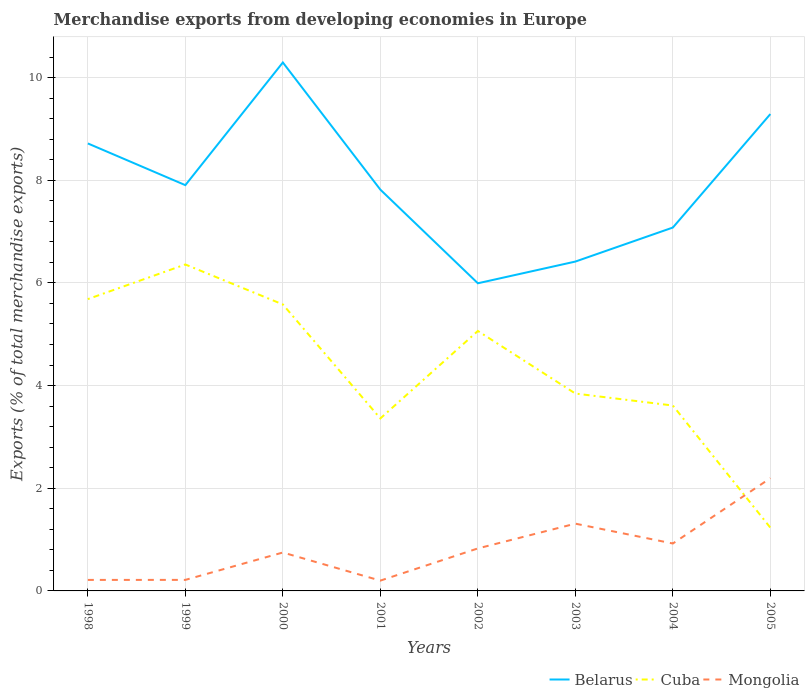Is the number of lines equal to the number of legend labels?
Provide a short and direct response. Yes. Across all years, what is the maximum percentage of total merchandise exports in Belarus?
Make the answer very short. 5.99. In which year was the percentage of total merchandise exports in Mongolia maximum?
Ensure brevity in your answer.  2001. What is the total percentage of total merchandise exports in Cuba in the graph?
Offer a terse response. 2.32. What is the difference between the highest and the second highest percentage of total merchandise exports in Belarus?
Provide a succinct answer. 4.3. What is the difference between the highest and the lowest percentage of total merchandise exports in Cuba?
Make the answer very short. 4. Is the percentage of total merchandise exports in Belarus strictly greater than the percentage of total merchandise exports in Mongolia over the years?
Provide a short and direct response. No. How many lines are there?
Keep it short and to the point. 3. What is the difference between two consecutive major ticks on the Y-axis?
Make the answer very short. 2. Are the values on the major ticks of Y-axis written in scientific E-notation?
Keep it short and to the point. No. Does the graph contain grids?
Offer a terse response. Yes. Where does the legend appear in the graph?
Provide a short and direct response. Bottom right. How many legend labels are there?
Provide a succinct answer. 3. How are the legend labels stacked?
Offer a very short reply. Horizontal. What is the title of the graph?
Ensure brevity in your answer.  Merchandise exports from developing economies in Europe. What is the label or title of the Y-axis?
Keep it short and to the point. Exports (% of total merchandise exports). What is the Exports (% of total merchandise exports) of Belarus in 1998?
Give a very brief answer. 8.72. What is the Exports (% of total merchandise exports) of Cuba in 1998?
Offer a terse response. 5.68. What is the Exports (% of total merchandise exports) in Mongolia in 1998?
Ensure brevity in your answer.  0.21. What is the Exports (% of total merchandise exports) in Belarus in 1999?
Ensure brevity in your answer.  7.9. What is the Exports (% of total merchandise exports) of Cuba in 1999?
Offer a very short reply. 6.36. What is the Exports (% of total merchandise exports) in Mongolia in 1999?
Give a very brief answer. 0.21. What is the Exports (% of total merchandise exports) in Belarus in 2000?
Provide a short and direct response. 10.29. What is the Exports (% of total merchandise exports) in Cuba in 2000?
Give a very brief answer. 5.58. What is the Exports (% of total merchandise exports) of Mongolia in 2000?
Your answer should be very brief. 0.75. What is the Exports (% of total merchandise exports) in Belarus in 2001?
Your response must be concise. 7.82. What is the Exports (% of total merchandise exports) in Cuba in 2001?
Give a very brief answer. 3.36. What is the Exports (% of total merchandise exports) of Mongolia in 2001?
Provide a succinct answer. 0.2. What is the Exports (% of total merchandise exports) in Belarus in 2002?
Make the answer very short. 5.99. What is the Exports (% of total merchandise exports) in Cuba in 2002?
Ensure brevity in your answer.  5.06. What is the Exports (% of total merchandise exports) in Mongolia in 2002?
Offer a very short reply. 0.83. What is the Exports (% of total merchandise exports) of Belarus in 2003?
Make the answer very short. 6.42. What is the Exports (% of total merchandise exports) of Cuba in 2003?
Your answer should be very brief. 3.85. What is the Exports (% of total merchandise exports) of Mongolia in 2003?
Give a very brief answer. 1.31. What is the Exports (% of total merchandise exports) in Belarus in 2004?
Offer a terse response. 7.08. What is the Exports (% of total merchandise exports) of Cuba in 2004?
Provide a succinct answer. 3.61. What is the Exports (% of total merchandise exports) of Mongolia in 2004?
Provide a short and direct response. 0.92. What is the Exports (% of total merchandise exports) of Belarus in 2005?
Offer a very short reply. 9.29. What is the Exports (% of total merchandise exports) in Cuba in 2005?
Ensure brevity in your answer.  1.23. What is the Exports (% of total merchandise exports) in Mongolia in 2005?
Your answer should be very brief. 2.2. Across all years, what is the maximum Exports (% of total merchandise exports) in Belarus?
Make the answer very short. 10.29. Across all years, what is the maximum Exports (% of total merchandise exports) in Cuba?
Give a very brief answer. 6.36. Across all years, what is the maximum Exports (% of total merchandise exports) in Mongolia?
Provide a short and direct response. 2.2. Across all years, what is the minimum Exports (% of total merchandise exports) of Belarus?
Provide a short and direct response. 5.99. Across all years, what is the minimum Exports (% of total merchandise exports) in Cuba?
Give a very brief answer. 1.23. Across all years, what is the minimum Exports (% of total merchandise exports) of Mongolia?
Your answer should be very brief. 0.2. What is the total Exports (% of total merchandise exports) of Belarus in the graph?
Your response must be concise. 63.51. What is the total Exports (% of total merchandise exports) of Cuba in the graph?
Make the answer very short. 34.74. What is the total Exports (% of total merchandise exports) in Mongolia in the graph?
Give a very brief answer. 6.64. What is the difference between the Exports (% of total merchandise exports) of Belarus in 1998 and that in 1999?
Give a very brief answer. 0.81. What is the difference between the Exports (% of total merchandise exports) of Cuba in 1998 and that in 1999?
Ensure brevity in your answer.  -0.67. What is the difference between the Exports (% of total merchandise exports) of Mongolia in 1998 and that in 1999?
Give a very brief answer. -0. What is the difference between the Exports (% of total merchandise exports) in Belarus in 1998 and that in 2000?
Provide a short and direct response. -1.58. What is the difference between the Exports (% of total merchandise exports) in Cuba in 1998 and that in 2000?
Your answer should be very brief. 0.1. What is the difference between the Exports (% of total merchandise exports) in Mongolia in 1998 and that in 2000?
Provide a succinct answer. -0.53. What is the difference between the Exports (% of total merchandise exports) in Belarus in 1998 and that in 2001?
Ensure brevity in your answer.  0.9. What is the difference between the Exports (% of total merchandise exports) of Cuba in 1998 and that in 2001?
Keep it short and to the point. 2.32. What is the difference between the Exports (% of total merchandise exports) of Mongolia in 1998 and that in 2001?
Make the answer very short. 0.01. What is the difference between the Exports (% of total merchandise exports) in Belarus in 1998 and that in 2002?
Provide a succinct answer. 2.72. What is the difference between the Exports (% of total merchandise exports) in Cuba in 1998 and that in 2002?
Give a very brief answer. 0.62. What is the difference between the Exports (% of total merchandise exports) in Mongolia in 1998 and that in 2002?
Give a very brief answer. -0.61. What is the difference between the Exports (% of total merchandise exports) of Belarus in 1998 and that in 2003?
Keep it short and to the point. 2.3. What is the difference between the Exports (% of total merchandise exports) in Cuba in 1998 and that in 2003?
Your response must be concise. 1.84. What is the difference between the Exports (% of total merchandise exports) in Mongolia in 1998 and that in 2003?
Keep it short and to the point. -1.1. What is the difference between the Exports (% of total merchandise exports) in Belarus in 1998 and that in 2004?
Your answer should be very brief. 1.64. What is the difference between the Exports (% of total merchandise exports) in Cuba in 1998 and that in 2004?
Offer a terse response. 2.07. What is the difference between the Exports (% of total merchandise exports) in Mongolia in 1998 and that in 2004?
Keep it short and to the point. -0.71. What is the difference between the Exports (% of total merchandise exports) in Belarus in 1998 and that in 2005?
Keep it short and to the point. -0.57. What is the difference between the Exports (% of total merchandise exports) in Cuba in 1998 and that in 2005?
Provide a succinct answer. 4.45. What is the difference between the Exports (% of total merchandise exports) of Mongolia in 1998 and that in 2005?
Make the answer very short. -1.98. What is the difference between the Exports (% of total merchandise exports) in Belarus in 1999 and that in 2000?
Offer a terse response. -2.39. What is the difference between the Exports (% of total merchandise exports) of Cuba in 1999 and that in 2000?
Provide a short and direct response. 0.78. What is the difference between the Exports (% of total merchandise exports) in Mongolia in 1999 and that in 2000?
Make the answer very short. -0.53. What is the difference between the Exports (% of total merchandise exports) in Belarus in 1999 and that in 2001?
Provide a short and direct response. 0.09. What is the difference between the Exports (% of total merchandise exports) of Cuba in 1999 and that in 2001?
Your answer should be compact. 3. What is the difference between the Exports (% of total merchandise exports) of Mongolia in 1999 and that in 2001?
Offer a terse response. 0.01. What is the difference between the Exports (% of total merchandise exports) in Belarus in 1999 and that in 2002?
Your answer should be compact. 1.91. What is the difference between the Exports (% of total merchandise exports) of Cuba in 1999 and that in 2002?
Ensure brevity in your answer.  1.3. What is the difference between the Exports (% of total merchandise exports) in Mongolia in 1999 and that in 2002?
Ensure brevity in your answer.  -0.61. What is the difference between the Exports (% of total merchandise exports) in Belarus in 1999 and that in 2003?
Provide a succinct answer. 1.49. What is the difference between the Exports (% of total merchandise exports) in Cuba in 1999 and that in 2003?
Offer a very short reply. 2.51. What is the difference between the Exports (% of total merchandise exports) in Mongolia in 1999 and that in 2003?
Keep it short and to the point. -1.1. What is the difference between the Exports (% of total merchandise exports) in Belarus in 1999 and that in 2004?
Offer a terse response. 0.83. What is the difference between the Exports (% of total merchandise exports) in Cuba in 1999 and that in 2004?
Provide a short and direct response. 2.75. What is the difference between the Exports (% of total merchandise exports) in Mongolia in 1999 and that in 2004?
Give a very brief answer. -0.71. What is the difference between the Exports (% of total merchandise exports) in Belarus in 1999 and that in 2005?
Offer a very short reply. -1.39. What is the difference between the Exports (% of total merchandise exports) in Cuba in 1999 and that in 2005?
Provide a short and direct response. 5.13. What is the difference between the Exports (% of total merchandise exports) in Mongolia in 1999 and that in 2005?
Give a very brief answer. -1.98. What is the difference between the Exports (% of total merchandise exports) of Belarus in 2000 and that in 2001?
Your response must be concise. 2.48. What is the difference between the Exports (% of total merchandise exports) of Cuba in 2000 and that in 2001?
Keep it short and to the point. 2.22. What is the difference between the Exports (% of total merchandise exports) in Mongolia in 2000 and that in 2001?
Ensure brevity in your answer.  0.55. What is the difference between the Exports (% of total merchandise exports) in Belarus in 2000 and that in 2002?
Your answer should be compact. 4.3. What is the difference between the Exports (% of total merchandise exports) of Cuba in 2000 and that in 2002?
Provide a short and direct response. 0.52. What is the difference between the Exports (% of total merchandise exports) of Mongolia in 2000 and that in 2002?
Ensure brevity in your answer.  -0.08. What is the difference between the Exports (% of total merchandise exports) of Belarus in 2000 and that in 2003?
Offer a terse response. 3.88. What is the difference between the Exports (% of total merchandise exports) in Cuba in 2000 and that in 2003?
Make the answer very short. 1.74. What is the difference between the Exports (% of total merchandise exports) of Mongolia in 2000 and that in 2003?
Ensure brevity in your answer.  -0.56. What is the difference between the Exports (% of total merchandise exports) of Belarus in 2000 and that in 2004?
Ensure brevity in your answer.  3.22. What is the difference between the Exports (% of total merchandise exports) in Cuba in 2000 and that in 2004?
Make the answer very short. 1.97. What is the difference between the Exports (% of total merchandise exports) of Mongolia in 2000 and that in 2004?
Make the answer very short. -0.18. What is the difference between the Exports (% of total merchandise exports) of Belarus in 2000 and that in 2005?
Your answer should be compact. 1. What is the difference between the Exports (% of total merchandise exports) of Cuba in 2000 and that in 2005?
Keep it short and to the point. 4.35. What is the difference between the Exports (% of total merchandise exports) in Mongolia in 2000 and that in 2005?
Ensure brevity in your answer.  -1.45. What is the difference between the Exports (% of total merchandise exports) of Belarus in 2001 and that in 2002?
Your answer should be very brief. 1.82. What is the difference between the Exports (% of total merchandise exports) of Cuba in 2001 and that in 2002?
Keep it short and to the point. -1.7. What is the difference between the Exports (% of total merchandise exports) in Mongolia in 2001 and that in 2002?
Your response must be concise. -0.63. What is the difference between the Exports (% of total merchandise exports) of Belarus in 2001 and that in 2003?
Keep it short and to the point. 1.4. What is the difference between the Exports (% of total merchandise exports) of Cuba in 2001 and that in 2003?
Keep it short and to the point. -0.48. What is the difference between the Exports (% of total merchandise exports) of Mongolia in 2001 and that in 2003?
Provide a succinct answer. -1.11. What is the difference between the Exports (% of total merchandise exports) of Belarus in 2001 and that in 2004?
Your answer should be compact. 0.74. What is the difference between the Exports (% of total merchandise exports) in Cuba in 2001 and that in 2004?
Offer a very short reply. -0.25. What is the difference between the Exports (% of total merchandise exports) of Mongolia in 2001 and that in 2004?
Ensure brevity in your answer.  -0.72. What is the difference between the Exports (% of total merchandise exports) of Belarus in 2001 and that in 2005?
Offer a terse response. -1.47. What is the difference between the Exports (% of total merchandise exports) in Cuba in 2001 and that in 2005?
Provide a short and direct response. 2.13. What is the difference between the Exports (% of total merchandise exports) of Mongolia in 2001 and that in 2005?
Provide a succinct answer. -2. What is the difference between the Exports (% of total merchandise exports) of Belarus in 2002 and that in 2003?
Give a very brief answer. -0.42. What is the difference between the Exports (% of total merchandise exports) of Cuba in 2002 and that in 2003?
Keep it short and to the point. 1.22. What is the difference between the Exports (% of total merchandise exports) in Mongolia in 2002 and that in 2003?
Give a very brief answer. -0.48. What is the difference between the Exports (% of total merchandise exports) in Belarus in 2002 and that in 2004?
Provide a succinct answer. -1.09. What is the difference between the Exports (% of total merchandise exports) of Cuba in 2002 and that in 2004?
Provide a short and direct response. 1.45. What is the difference between the Exports (% of total merchandise exports) in Mongolia in 2002 and that in 2004?
Provide a short and direct response. -0.1. What is the difference between the Exports (% of total merchandise exports) of Belarus in 2002 and that in 2005?
Provide a succinct answer. -3.3. What is the difference between the Exports (% of total merchandise exports) of Cuba in 2002 and that in 2005?
Your answer should be very brief. 3.83. What is the difference between the Exports (% of total merchandise exports) in Mongolia in 2002 and that in 2005?
Keep it short and to the point. -1.37. What is the difference between the Exports (% of total merchandise exports) of Belarus in 2003 and that in 2004?
Your answer should be compact. -0.66. What is the difference between the Exports (% of total merchandise exports) of Cuba in 2003 and that in 2004?
Keep it short and to the point. 0.23. What is the difference between the Exports (% of total merchandise exports) of Mongolia in 2003 and that in 2004?
Offer a very short reply. 0.39. What is the difference between the Exports (% of total merchandise exports) of Belarus in 2003 and that in 2005?
Provide a succinct answer. -2.87. What is the difference between the Exports (% of total merchandise exports) in Cuba in 2003 and that in 2005?
Offer a terse response. 2.61. What is the difference between the Exports (% of total merchandise exports) of Mongolia in 2003 and that in 2005?
Give a very brief answer. -0.89. What is the difference between the Exports (% of total merchandise exports) of Belarus in 2004 and that in 2005?
Give a very brief answer. -2.21. What is the difference between the Exports (% of total merchandise exports) in Cuba in 2004 and that in 2005?
Your answer should be compact. 2.38. What is the difference between the Exports (% of total merchandise exports) in Mongolia in 2004 and that in 2005?
Provide a short and direct response. -1.27. What is the difference between the Exports (% of total merchandise exports) of Belarus in 1998 and the Exports (% of total merchandise exports) of Cuba in 1999?
Offer a very short reply. 2.36. What is the difference between the Exports (% of total merchandise exports) in Belarus in 1998 and the Exports (% of total merchandise exports) in Mongolia in 1999?
Give a very brief answer. 8.5. What is the difference between the Exports (% of total merchandise exports) in Cuba in 1998 and the Exports (% of total merchandise exports) in Mongolia in 1999?
Make the answer very short. 5.47. What is the difference between the Exports (% of total merchandise exports) in Belarus in 1998 and the Exports (% of total merchandise exports) in Cuba in 2000?
Your response must be concise. 3.14. What is the difference between the Exports (% of total merchandise exports) in Belarus in 1998 and the Exports (% of total merchandise exports) in Mongolia in 2000?
Keep it short and to the point. 7.97. What is the difference between the Exports (% of total merchandise exports) of Cuba in 1998 and the Exports (% of total merchandise exports) of Mongolia in 2000?
Make the answer very short. 4.94. What is the difference between the Exports (% of total merchandise exports) in Belarus in 1998 and the Exports (% of total merchandise exports) in Cuba in 2001?
Give a very brief answer. 5.36. What is the difference between the Exports (% of total merchandise exports) in Belarus in 1998 and the Exports (% of total merchandise exports) in Mongolia in 2001?
Make the answer very short. 8.52. What is the difference between the Exports (% of total merchandise exports) of Cuba in 1998 and the Exports (% of total merchandise exports) of Mongolia in 2001?
Offer a terse response. 5.48. What is the difference between the Exports (% of total merchandise exports) in Belarus in 1998 and the Exports (% of total merchandise exports) in Cuba in 2002?
Your answer should be very brief. 3.65. What is the difference between the Exports (% of total merchandise exports) of Belarus in 1998 and the Exports (% of total merchandise exports) of Mongolia in 2002?
Your answer should be very brief. 7.89. What is the difference between the Exports (% of total merchandise exports) in Cuba in 1998 and the Exports (% of total merchandise exports) in Mongolia in 2002?
Offer a terse response. 4.86. What is the difference between the Exports (% of total merchandise exports) of Belarus in 1998 and the Exports (% of total merchandise exports) of Cuba in 2003?
Give a very brief answer. 4.87. What is the difference between the Exports (% of total merchandise exports) of Belarus in 1998 and the Exports (% of total merchandise exports) of Mongolia in 2003?
Provide a short and direct response. 7.41. What is the difference between the Exports (% of total merchandise exports) of Cuba in 1998 and the Exports (% of total merchandise exports) of Mongolia in 2003?
Your answer should be compact. 4.37. What is the difference between the Exports (% of total merchandise exports) in Belarus in 1998 and the Exports (% of total merchandise exports) in Cuba in 2004?
Make the answer very short. 5.11. What is the difference between the Exports (% of total merchandise exports) in Belarus in 1998 and the Exports (% of total merchandise exports) in Mongolia in 2004?
Offer a terse response. 7.79. What is the difference between the Exports (% of total merchandise exports) in Cuba in 1998 and the Exports (% of total merchandise exports) in Mongolia in 2004?
Provide a short and direct response. 4.76. What is the difference between the Exports (% of total merchandise exports) of Belarus in 1998 and the Exports (% of total merchandise exports) of Cuba in 2005?
Your answer should be compact. 7.49. What is the difference between the Exports (% of total merchandise exports) in Belarus in 1998 and the Exports (% of total merchandise exports) in Mongolia in 2005?
Provide a succinct answer. 6.52. What is the difference between the Exports (% of total merchandise exports) of Cuba in 1998 and the Exports (% of total merchandise exports) of Mongolia in 2005?
Your answer should be very brief. 3.49. What is the difference between the Exports (% of total merchandise exports) of Belarus in 1999 and the Exports (% of total merchandise exports) of Cuba in 2000?
Offer a very short reply. 2.32. What is the difference between the Exports (% of total merchandise exports) of Belarus in 1999 and the Exports (% of total merchandise exports) of Mongolia in 2000?
Your answer should be compact. 7.16. What is the difference between the Exports (% of total merchandise exports) of Cuba in 1999 and the Exports (% of total merchandise exports) of Mongolia in 2000?
Make the answer very short. 5.61. What is the difference between the Exports (% of total merchandise exports) of Belarus in 1999 and the Exports (% of total merchandise exports) of Cuba in 2001?
Offer a terse response. 4.54. What is the difference between the Exports (% of total merchandise exports) of Belarus in 1999 and the Exports (% of total merchandise exports) of Mongolia in 2001?
Ensure brevity in your answer.  7.7. What is the difference between the Exports (% of total merchandise exports) in Cuba in 1999 and the Exports (% of total merchandise exports) in Mongolia in 2001?
Make the answer very short. 6.16. What is the difference between the Exports (% of total merchandise exports) in Belarus in 1999 and the Exports (% of total merchandise exports) in Cuba in 2002?
Your answer should be compact. 2.84. What is the difference between the Exports (% of total merchandise exports) in Belarus in 1999 and the Exports (% of total merchandise exports) in Mongolia in 2002?
Give a very brief answer. 7.08. What is the difference between the Exports (% of total merchandise exports) of Cuba in 1999 and the Exports (% of total merchandise exports) of Mongolia in 2002?
Your answer should be compact. 5.53. What is the difference between the Exports (% of total merchandise exports) in Belarus in 1999 and the Exports (% of total merchandise exports) in Cuba in 2003?
Ensure brevity in your answer.  4.06. What is the difference between the Exports (% of total merchandise exports) in Belarus in 1999 and the Exports (% of total merchandise exports) in Mongolia in 2003?
Offer a terse response. 6.59. What is the difference between the Exports (% of total merchandise exports) of Cuba in 1999 and the Exports (% of total merchandise exports) of Mongolia in 2003?
Your answer should be very brief. 5.05. What is the difference between the Exports (% of total merchandise exports) in Belarus in 1999 and the Exports (% of total merchandise exports) in Cuba in 2004?
Your response must be concise. 4.29. What is the difference between the Exports (% of total merchandise exports) in Belarus in 1999 and the Exports (% of total merchandise exports) in Mongolia in 2004?
Give a very brief answer. 6.98. What is the difference between the Exports (% of total merchandise exports) of Cuba in 1999 and the Exports (% of total merchandise exports) of Mongolia in 2004?
Provide a succinct answer. 5.44. What is the difference between the Exports (% of total merchandise exports) of Belarus in 1999 and the Exports (% of total merchandise exports) of Cuba in 2005?
Provide a succinct answer. 6.67. What is the difference between the Exports (% of total merchandise exports) of Belarus in 1999 and the Exports (% of total merchandise exports) of Mongolia in 2005?
Offer a very short reply. 5.71. What is the difference between the Exports (% of total merchandise exports) in Cuba in 1999 and the Exports (% of total merchandise exports) in Mongolia in 2005?
Provide a succinct answer. 4.16. What is the difference between the Exports (% of total merchandise exports) of Belarus in 2000 and the Exports (% of total merchandise exports) of Cuba in 2001?
Provide a succinct answer. 6.93. What is the difference between the Exports (% of total merchandise exports) in Belarus in 2000 and the Exports (% of total merchandise exports) in Mongolia in 2001?
Your response must be concise. 10.09. What is the difference between the Exports (% of total merchandise exports) in Cuba in 2000 and the Exports (% of total merchandise exports) in Mongolia in 2001?
Provide a short and direct response. 5.38. What is the difference between the Exports (% of total merchandise exports) of Belarus in 2000 and the Exports (% of total merchandise exports) of Cuba in 2002?
Provide a short and direct response. 5.23. What is the difference between the Exports (% of total merchandise exports) in Belarus in 2000 and the Exports (% of total merchandise exports) in Mongolia in 2002?
Your answer should be very brief. 9.47. What is the difference between the Exports (% of total merchandise exports) of Cuba in 2000 and the Exports (% of total merchandise exports) of Mongolia in 2002?
Provide a succinct answer. 4.75. What is the difference between the Exports (% of total merchandise exports) in Belarus in 2000 and the Exports (% of total merchandise exports) in Cuba in 2003?
Keep it short and to the point. 6.45. What is the difference between the Exports (% of total merchandise exports) in Belarus in 2000 and the Exports (% of total merchandise exports) in Mongolia in 2003?
Ensure brevity in your answer.  8.98. What is the difference between the Exports (% of total merchandise exports) in Cuba in 2000 and the Exports (% of total merchandise exports) in Mongolia in 2003?
Give a very brief answer. 4.27. What is the difference between the Exports (% of total merchandise exports) in Belarus in 2000 and the Exports (% of total merchandise exports) in Cuba in 2004?
Your answer should be compact. 6.68. What is the difference between the Exports (% of total merchandise exports) of Belarus in 2000 and the Exports (% of total merchandise exports) of Mongolia in 2004?
Provide a short and direct response. 9.37. What is the difference between the Exports (% of total merchandise exports) in Cuba in 2000 and the Exports (% of total merchandise exports) in Mongolia in 2004?
Provide a succinct answer. 4.66. What is the difference between the Exports (% of total merchandise exports) of Belarus in 2000 and the Exports (% of total merchandise exports) of Cuba in 2005?
Keep it short and to the point. 9.06. What is the difference between the Exports (% of total merchandise exports) of Belarus in 2000 and the Exports (% of total merchandise exports) of Mongolia in 2005?
Your response must be concise. 8.1. What is the difference between the Exports (% of total merchandise exports) of Cuba in 2000 and the Exports (% of total merchandise exports) of Mongolia in 2005?
Your answer should be compact. 3.38. What is the difference between the Exports (% of total merchandise exports) in Belarus in 2001 and the Exports (% of total merchandise exports) in Cuba in 2002?
Keep it short and to the point. 2.75. What is the difference between the Exports (% of total merchandise exports) in Belarus in 2001 and the Exports (% of total merchandise exports) in Mongolia in 2002?
Give a very brief answer. 6.99. What is the difference between the Exports (% of total merchandise exports) in Cuba in 2001 and the Exports (% of total merchandise exports) in Mongolia in 2002?
Provide a succinct answer. 2.53. What is the difference between the Exports (% of total merchandise exports) in Belarus in 2001 and the Exports (% of total merchandise exports) in Cuba in 2003?
Give a very brief answer. 3.97. What is the difference between the Exports (% of total merchandise exports) of Belarus in 2001 and the Exports (% of total merchandise exports) of Mongolia in 2003?
Keep it short and to the point. 6.51. What is the difference between the Exports (% of total merchandise exports) in Cuba in 2001 and the Exports (% of total merchandise exports) in Mongolia in 2003?
Make the answer very short. 2.05. What is the difference between the Exports (% of total merchandise exports) in Belarus in 2001 and the Exports (% of total merchandise exports) in Cuba in 2004?
Make the answer very short. 4.21. What is the difference between the Exports (% of total merchandise exports) in Belarus in 2001 and the Exports (% of total merchandise exports) in Mongolia in 2004?
Keep it short and to the point. 6.89. What is the difference between the Exports (% of total merchandise exports) in Cuba in 2001 and the Exports (% of total merchandise exports) in Mongolia in 2004?
Ensure brevity in your answer.  2.44. What is the difference between the Exports (% of total merchandise exports) in Belarus in 2001 and the Exports (% of total merchandise exports) in Cuba in 2005?
Ensure brevity in your answer.  6.59. What is the difference between the Exports (% of total merchandise exports) of Belarus in 2001 and the Exports (% of total merchandise exports) of Mongolia in 2005?
Keep it short and to the point. 5.62. What is the difference between the Exports (% of total merchandise exports) in Cuba in 2001 and the Exports (% of total merchandise exports) in Mongolia in 2005?
Your response must be concise. 1.16. What is the difference between the Exports (% of total merchandise exports) in Belarus in 2002 and the Exports (% of total merchandise exports) in Cuba in 2003?
Offer a very short reply. 2.15. What is the difference between the Exports (% of total merchandise exports) in Belarus in 2002 and the Exports (% of total merchandise exports) in Mongolia in 2003?
Keep it short and to the point. 4.68. What is the difference between the Exports (% of total merchandise exports) of Cuba in 2002 and the Exports (% of total merchandise exports) of Mongolia in 2003?
Your answer should be very brief. 3.75. What is the difference between the Exports (% of total merchandise exports) of Belarus in 2002 and the Exports (% of total merchandise exports) of Cuba in 2004?
Keep it short and to the point. 2.38. What is the difference between the Exports (% of total merchandise exports) in Belarus in 2002 and the Exports (% of total merchandise exports) in Mongolia in 2004?
Make the answer very short. 5.07. What is the difference between the Exports (% of total merchandise exports) in Cuba in 2002 and the Exports (% of total merchandise exports) in Mongolia in 2004?
Keep it short and to the point. 4.14. What is the difference between the Exports (% of total merchandise exports) in Belarus in 2002 and the Exports (% of total merchandise exports) in Cuba in 2005?
Your response must be concise. 4.76. What is the difference between the Exports (% of total merchandise exports) of Belarus in 2002 and the Exports (% of total merchandise exports) of Mongolia in 2005?
Provide a succinct answer. 3.8. What is the difference between the Exports (% of total merchandise exports) of Cuba in 2002 and the Exports (% of total merchandise exports) of Mongolia in 2005?
Offer a terse response. 2.87. What is the difference between the Exports (% of total merchandise exports) of Belarus in 2003 and the Exports (% of total merchandise exports) of Cuba in 2004?
Offer a terse response. 2.8. What is the difference between the Exports (% of total merchandise exports) in Belarus in 2003 and the Exports (% of total merchandise exports) in Mongolia in 2004?
Give a very brief answer. 5.49. What is the difference between the Exports (% of total merchandise exports) of Cuba in 2003 and the Exports (% of total merchandise exports) of Mongolia in 2004?
Provide a succinct answer. 2.92. What is the difference between the Exports (% of total merchandise exports) in Belarus in 2003 and the Exports (% of total merchandise exports) in Cuba in 2005?
Make the answer very short. 5.18. What is the difference between the Exports (% of total merchandise exports) in Belarus in 2003 and the Exports (% of total merchandise exports) in Mongolia in 2005?
Ensure brevity in your answer.  4.22. What is the difference between the Exports (% of total merchandise exports) of Cuba in 2003 and the Exports (% of total merchandise exports) of Mongolia in 2005?
Ensure brevity in your answer.  1.65. What is the difference between the Exports (% of total merchandise exports) of Belarus in 2004 and the Exports (% of total merchandise exports) of Cuba in 2005?
Your response must be concise. 5.85. What is the difference between the Exports (% of total merchandise exports) in Belarus in 2004 and the Exports (% of total merchandise exports) in Mongolia in 2005?
Offer a terse response. 4.88. What is the difference between the Exports (% of total merchandise exports) of Cuba in 2004 and the Exports (% of total merchandise exports) of Mongolia in 2005?
Keep it short and to the point. 1.42. What is the average Exports (% of total merchandise exports) in Belarus per year?
Your answer should be compact. 7.94. What is the average Exports (% of total merchandise exports) of Cuba per year?
Your answer should be very brief. 4.34. What is the average Exports (% of total merchandise exports) of Mongolia per year?
Ensure brevity in your answer.  0.83. In the year 1998, what is the difference between the Exports (% of total merchandise exports) in Belarus and Exports (% of total merchandise exports) in Cuba?
Keep it short and to the point. 3.03. In the year 1998, what is the difference between the Exports (% of total merchandise exports) of Belarus and Exports (% of total merchandise exports) of Mongolia?
Make the answer very short. 8.5. In the year 1998, what is the difference between the Exports (% of total merchandise exports) of Cuba and Exports (% of total merchandise exports) of Mongolia?
Your answer should be very brief. 5.47. In the year 1999, what is the difference between the Exports (% of total merchandise exports) in Belarus and Exports (% of total merchandise exports) in Cuba?
Your answer should be very brief. 1.55. In the year 1999, what is the difference between the Exports (% of total merchandise exports) of Belarus and Exports (% of total merchandise exports) of Mongolia?
Give a very brief answer. 7.69. In the year 1999, what is the difference between the Exports (% of total merchandise exports) in Cuba and Exports (% of total merchandise exports) in Mongolia?
Give a very brief answer. 6.14. In the year 2000, what is the difference between the Exports (% of total merchandise exports) in Belarus and Exports (% of total merchandise exports) in Cuba?
Your answer should be very brief. 4.71. In the year 2000, what is the difference between the Exports (% of total merchandise exports) in Belarus and Exports (% of total merchandise exports) in Mongolia?
Offer a terse response. 9.55. In the year 2000, what is the difference between the Exports (% of total merchandise exports) in Cuba and Exports (% of total merchandise exports) in Mongolia?
Your answer should be compact. 4.83. In the year 2001, what is the difference between the Exports (% of total merchandise exports) in Belarus and Exports (% of total merchandise exports) in Cuba?
Offer a very short reply. 4.46. In the year 2001, what is the difference between the Exports (% of total merchandise exports) of Belarus and Exports (% of total merchandise exports) of Mongolia?
Offer a very short reply. 7.62. In the year 2001, what is the difference between the Exports (% of total merchandise exports) of Cuba and Exports (% of total merchandise exports) of Mongolia?
Offer a very short reply. 3.16. In the year 2002, what is the difference between the Exports (% of total merchandise exports) of Belarus and Exports (% of total merchandise exports) of Cuba?
Keep it short and to the point. 0.93. In the year 2002, what is the difference between the Exports (% of total merchandise exports) of Belarus and Exports (% of total merchandise exports) of Mongolia?
Provide a succinct answer. 5.17. In the year 2002, what is the difference between the Exports (% of total merchandise exports) in Cuba and Exports (% of total merchandise exports) in Mongolia?
Provide a short and direct response. 4.24. In the year 2003, what is the difference between the Exports (% of total merchandise exports) in Belarus and Exports (% of total merchandise exports) in Cuba?
Your answer should be very brief. 2.57. In the year 2003, what is the difference between the Exports (% of total merchandise exports) in Belarus and Exports (% of total merchandise exports) in Mongolia?
Offer a terse response. 5.11. In the year 2003, what is the difference between the Exports (% of total merchandise exports) of Cuba and Exports (% of total merchandise exports) of Mongolia?
Give a very brief answer. 2.53. In the year 2004, what is the difference between the Exports (% of total merchandise exports) in Belarus and Exports (% of total merchandise exports) in Cuba?
Offer a terse response. 3.47. In the year 2004, what is the difference between the Exports (% of total merchandise exports) in Belarus and Exports (% of total merchandise exports) in Mongolia?
Provide a short and direct response. 6.16. In the year 2004, what is the difference between the Exports (% of total merchandise exports) of Cuba and Exports (% of total merchandise exports) of Mongolia?
Offer a terse response. 2.69. In the year 2005, what is the difference between the Exports (% of total merchandise exports) of Belarus and Exports (% of total merchandise exports) of Cuba?
Keep it short and to the point. 8.06. In the year 2005, what is the difference between the Exports (% of total merchandise exports) in Belarus and Exports (% of total merchandise exports) in Mongolia?
Your response must be concise. 7.09. In the year 2005, what is the difference between the Exports (% of total merchandise exports) of Cuba and Exports (% of total merchandise exports) of Mongolia?
Provide a succinct answer. -0.96. What is the ratio of the Exports (% of total merchandise exports) in Belarus in 1998 to that in 1999?
Your answer should be compact. 1.1. What is the ratio of the Exports (% of total merchandise exports) in Cuba in 1998 to that in 1999?
Make the answer very short. 0.89. What is the ratio of the Exports (% of total merchandise exports) in Mongolia in 1998 to that in 1999?
Provide a succinct answer. 1. What is the ratio of the Exports (% of total merchandise exports) in Belarus in 1998 to that in 2000?
Provide a short and direct response. 0.85. What is the ratio of the Exports (% of total merchandise exports) of Cuba in 1998 to that in 2000?
Provide a short and direct response. 1.02. What is the ratio of the Exports (% of total merchandise exports) in Mongolia in 1998 to that in 2000?
Your response must be concise. 0.29. What is the ratio of the Exports (% of total merchandise exports) in Belarus in 1998 to that in 2001?
Your answer should be compact. 1.12. What is the ratio of the Exports (% of total merchandise exports) of Cuba in 1998 to that in 2001?
Give a very brief answer. 1.69. What is the ratio of the Exports (% of total merchandise exports) of Mongolia in 1998 to that in 2001?
Give a very brief answer. 1.07. What is the ratio of the Exports (% of total merchandise exports) in Belarus in 1998 to that in 2002?
Offer a terse response. 1.45. What is the ratio of the Exports (% of total merchandise exports) in Cuba in 1998 to that in 2002?
Offer a terse response. 1.12. What is the ratio of the Exports (% of total merchandise exports) of Mongolia in 1998 to that in 2002?
Your response must be concise. 0.26. What is the ratio of the Exports (% of total merchandise exports) in Belarus in 1998 to that in 2003?
Offer a very short reply. 1.36. What is the ratio of the Exports (% of total merchandise exports) of Cuba in 1998 to that in 2003?
Your answer should be very brief. 1.48. What is the ratio of the Exports (% of total merchandise exports) of Mongolia in 1998 to that in 2003?
Your answer should be very brief. 0.16. What is the ratio of the Exports (% of total merchandise exports) in Belarus in 1998 to that in 2004?
Provide a succinct answer. 1.23. What is the ratio of the Exports (% of total merchandise exports) of Cuba in 1998 to that in 2004?
Make the answer very short. 1.57. What is the ratio of the Exports (% of total merchandise exports) of Mongolia in 1998 to that in 2004?
Provide a succinct answer. 0.23. What is the ratio of the Exports (% of total merchandise exports) of Belarus in 1998 to that in 2005?
Offer a terse response. 0.94. What is the ratio of the Exports (% of total merchandise exports) in Cuba in 1998 to that in 2005?
Give a very brief answer. 4.62. What is the ratio of the Exports (% of total merchandise exports) of Mongolia in 1998 to that in 2005?
Offer a very short reply. 0.1. What is the ratio of the Exports (% of total merchandise exports) of Belarus in 1999 to that in 2000?
Offer a terse response. 0.77. What is the ratio of the Exports (% of total merchandise exports) of Cuba in 1999 to that in 2000?
Offer a terse response. 1.14. What is the ratio of the Exports (% of total merchandise exports) in Mongolia in 1999 to that in 2000?
Your response must be concise. 0.29. What is the ratio of the Exports (% of total merchandise exports) in Belarus in 1999 to that in 2001?
Keep it short and to the point. 1.01. What is the ratio of the Exports (% of total merchandise exports) of Cuba in 1999 to that in 2001?
Your answer should be compact. 1.89. What is the ratio of the Exports (% of total merchandise exports) of Mongolia in 1999 to that in 2001?
Your answer should be very brief. 1.07. What is the ratio of the Exports (% of total merchandise exports) of Belarus in 1999 to that in 2002?
Provide a succinct answer. 1.32. What is the ratio of the Exports (% of total merchandise exports) in Cuba in 1999 to that in 2002?
Offer a very short reply. 1.26. What is the ratio of the Exports (% of total merchandise exports) in Mongolia in 1999 to that in 2002?
Keep it short and to the point. 0.26. What is the ratio of the Exports (% of total merchandise exports) in Belarus in 1999 to that in 2003?
Make the answer very short. 1.23. What is the ratio of the Exports (% of total merchandise exports) in Cuba in 1999 to that in 2003?
Keep it short and to the point. 1.65. What is the ratio of the Exports (% of total merchandise exports) of Mongolia in 1999 to that in 2003?
Keep it short and to the point. 0.16. What is the ratio of the Exports (% of total merchandise exports) of Belarus in 1999 to that in 2004?
Your answer should be compact. 1.12. What is the ratio of the Exports (% of total merchandise exports) of Cuba in 1999 to that in 2004?
Offer a terse response. 1.76. What is the ratio of the Exports (% of total merchandise exports) of Mongolia in 1999 to that in 2004?
Your answer should be very brief. 0.23. What is the ratio of the Exports (% of total merchandise exports) of Belarus in 1999 to that in 2005?
Provide a short and direct response. 0.85. What is the ratio of the Exports (% of total merchandise exports) of Cuba in 1999 to that in 2005?
Your response must be concise. 5.16. What is the ratio of the Exports (% of total merchandise exports) of Mongolia in 1999 to that in 2005?
Your answer should be compact. 0.1. What is the ratio of the Exports (% of total merchandise exports) in Belarus in 2000 to that in 2001?
Keep it short and to the point. 1.32. What is the ratio of the Exports (% of total merchandise exports) in Cuba in 2000 to that in 2001?
Give a very brief answer. 1.66. What is the ratio of the Exports (% of total merchandise exports) of Mongolia in 2000 to that in 2001?
Provide a short and direct response. 3.73. What is the ratio of the Exports (% of total merchandise exports) of Belarus in 2000 to that in 2002?
Your answer should be compact. 1.72. What is the ratio of the Exports (% of total merchandise exports) of Cuba in 2000 to that in 2002?
Offer a very short reply. 1.1. What is the ratio of the Exports (% of total merchandise exports) in Mongolia in 2000 to that in 2002?
Your response must be concise. 0.9. What is the ratio of the Exports (% of total merchandise exports) of Belarus in 2000 to that in 2003?
Your answer should be compact. 1.6. What is the ratio of the Exports (% of total merchandise exports) in Cuba in 2000 to that in 2003?
Provide a succinct answer. 1.45. What is the ratio of the Exports (% of total merchandise exports) in Mongolia in 2000 to that in 2003?
Keep it short and to the point. 0.57. What is the ratio of the Exports (% of total merchandise exports) in Belarus in 2000 to that in 2004?
Provide a succinct answer. 1.45. What is the ratio of the Exports (% of total merchandise exports) of Cuba in 2000 to that in 2004?
Provide a succinct answer. 1.55. What is the ratio of the Exports (% of total merchandise exports) of Mongolia in 2000 to that in 2004?
Offer a very short reply. 0.81. What is the ratio of the Exports (% of total merchandise exports) in Belarus in 2000 to that in 2005?
Offer a very short reply. 1.11. What is the ratio of the Exports (% of total merchandise exports) of Cuba in 2000 to that in 2005?
Your response must be concise. 4.53. What is the ratio of the Exports (% of total merchandise exports) in Mongolia in 2000 to that in 2005?
Keep it short and to the point. 0.34. What is the ratio of the Exports (% of total merchandise exports) of Belarus in 2001 to that in 2002?
Ensure brevity in your answer.  1.3. What is the ratio of the Exports (% of total merchandise exports) of Cuba in 2001 to that in 2002?
Your answer should be compact. 0.66. What is the ratio of the Exports (% of total merchandise exports) in Mongolia in 2001 to that in 2002?
Give a very brief answer. 0.24. What is the ratio of the Exports (% of total merchandise exports) in Belarus in 2001 to that in 2003?
Make the answer very short. 1.22. What is the ratio of the Exports (% of total merchandise exports) of Cuba in 2001 to that in 2003?
Make the answer very short. 0.87. What is the ratio of the Exports (% of total merchandise exports) of Mongolia in 2001 to that in 2003?
Your response must be concise. 0.15. What is the ratio of the Exports (% of total merchandise exports) of Belarus in 2001 to that in 2004?
Offer a terse response. 1.1. What is the ratio of the Exports (% of total merchandise exports) of Cuba in 2001 to that in 2004?
Provide a short and direct response. 0.93. What is the ratio of the Exports (% of total merchandise exports) of Mongolia in 2001 to that in 2004?
Offer a very short reply. 0.22. What is the ratio of the Exports (% of total merchandise exports) of Belarus in 2001 to that in 2005?
Keep it short and to the point. 0.84. What is the ratio of the Exports (% of total merchandise exports) of Cuba in 2001 to that in 2005?
Offer a terse response. 2.73. What is the ratio of the Exports (% of total merchandise exports) of Mongolia in 2001 to that in 2005?
Offer a very short reply. 0.09. What is the ratio of the Exports (% of total merchandise exports) in Belarus in 2002 to that in 2003?
Your answer should be very brief. 0.93. What is the ratio of the Exports (% of total merchandise exports) of Cuba in 2002 to that in 2003?
Give a very brief answer. 1.32. What is the ratio of the Exports (% of total merchandise exports) of Mongolia in 2002 to that in 2003?
Keep it short and to the point. 0.63. What is the ratio of the Exports (% of total merchandise exports) in Belarus in 2002 to that in 2004?
Give a very brief answer. 0.85. What is the ratio of the Exports (% of total merchandise exports) of Cuba in 2002 to that in 2004?
Provide a short and direct response. 1.4. What is the ratio of the Exports (% of total merchandise exports) in Mongolia in 2002 to that in 2004?
Give a very brief answer. 0.9. What is the ratio of the Exports (% of total merchandise exports) in Belarus in 2002 to that in 2005?
Your answer should be very brief. 0.65. What is the ratio of the Exports (% of total merchandise exports) of Cuba in 2002 to that in 2005?
Offer a very short reply. 4.11. What is the ratio of the Exports (% of total merchandise exports) in Mongolia in 2002 to that in 2005?
Ensure brevity in your answer.  0.38. What is the ratio of the Exports (% of total merchandise exports) of Belarus in 2003 to that in 2004?
Your answer should be compact. 0.91. What is the ratio of the Exports (% of total merchandise exports) in Cuba in 2003 to that in 2004?
Provide a short and direct response. 1.06. What is the ratio of the Exports (% of total merchandise exports) of Mongolia in 2003 to that in 2004?
Your answer should be very brief. 1.42. What is the ratio of the Exports (% of total merchandise exports) in Belarus in 2003 to that in 2005?
Ensure brevity in your answer.  0.69. What is the ratio of the Exports (% of total merchandise exports) in Cuba in 2003 to that in 2005?
Your answer should be very brief. 3.12. What is the ratio of the Exports (% of total merchandise exports) of Mongolia in 2003 to that in 2005?
Ensure brevity in your answer.  0.6. What is the ratio of the Exports (% of total merchandise exports) of Belarus in 2004 to that in 2005?
Make the answer very short. 0.76. What is the ratio of the Exports (% of total merchandise exports) in Cuba in 2004 to that in 2005?
Give a very brief answer. 2.93. What is the ratio of the Exports (% of total merchandise exports) in Mongolia in 2004 to that in 2005?
Keep it short and to the point. 0.42. What is the difference between the highest and the second highest Exports (% of total merchandise exports) in Cuba?
Offer a very short reply. 0.67. What is the difference between the highest and the second highest Exports (% of total merchandise exports) in Mongolia?
Your answer should be very brief. 0.89. What is the difference between the highest and the lowest Exports (% of total merchandise exports) of Belarus?
Your answer should be compact. 4.3. What is the difference between the highest and the lowest Exports (% of total merchandise exports) in Cuba?
Offer a very short reply. 5.13. What is the difference between the highest and the lowest Exports (% of total merchandise exports) in Mongolia?
Your response must be concise. 2. 